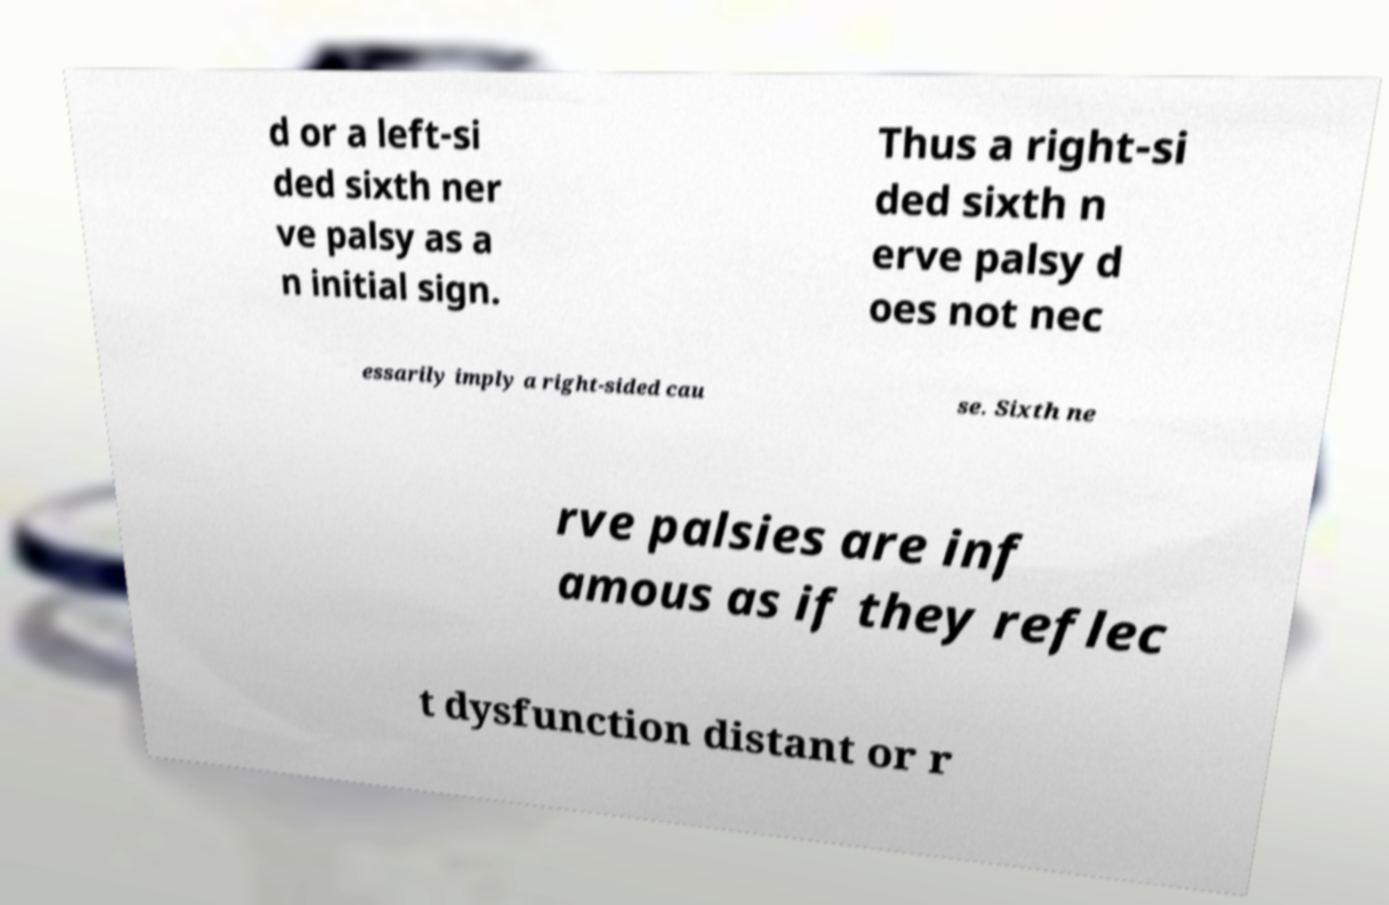For documentation purposes, I need the text within this image transcribed. Could you provide that? d or a left-si ded sixth ner ve palsy as a n initial sign. Thus a right-si ded sixth n erve palsy d oes not nec essarily imply a right-sided cau se. Sixth ne rve palsies are inf amous as if they reflec t dysfunction distant or r 